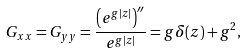Convert formula to latex. <formula><loc_0><loc_0><loc_500><loc_500>G _ { x x } = G _ { y y } = \frac { \left ( e ^ { g | z | } \right ) ^ { \prime \prime } } { e ^ { g | z | } } = g \delta ( z ) + g ^ { 2 } ,</formula> 